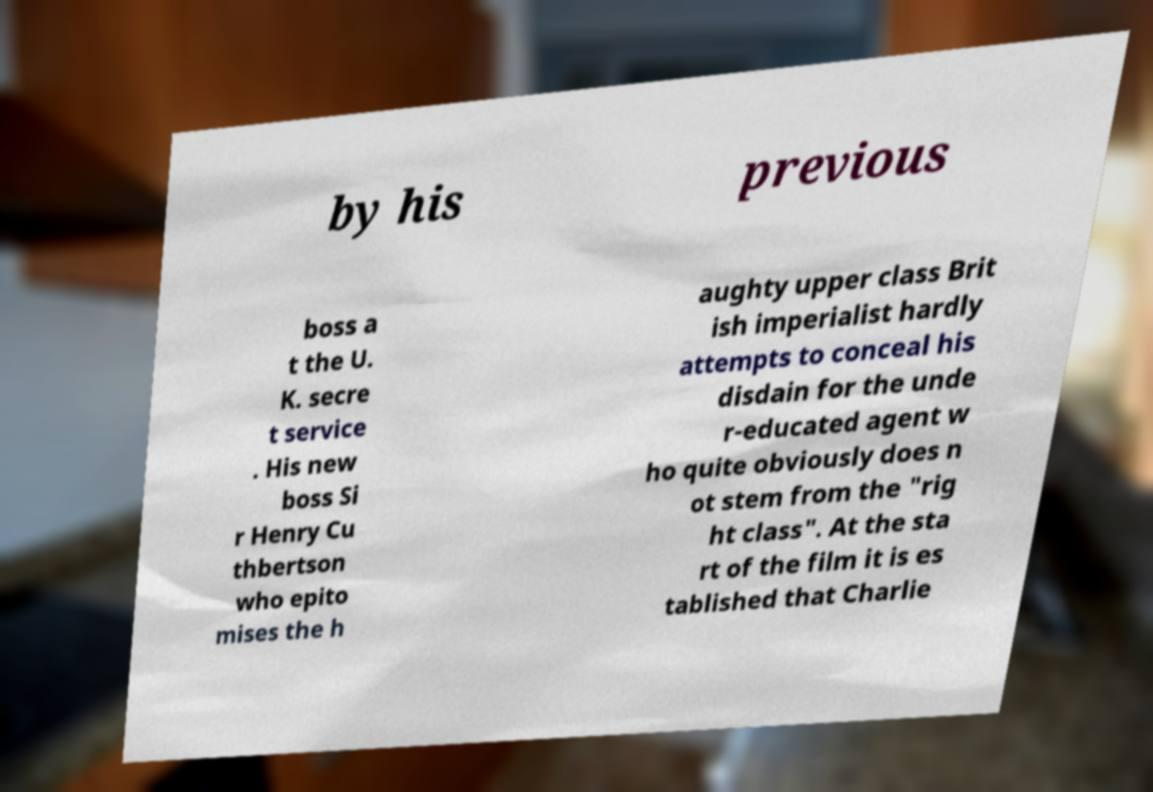Please identify and transcribe the text found in this image. by his previous boss a t the U. K. secre t service . His new boss Si r Henry Cu thbertson who epito mises the h aughty upper class Brit ish imperialist hardly attempts to conceal his disdain for the unde r-educated agent w ho quite obviously does n ot stem from the "rig ht class". At the sta rt of the film it is es tablished that Charlie 